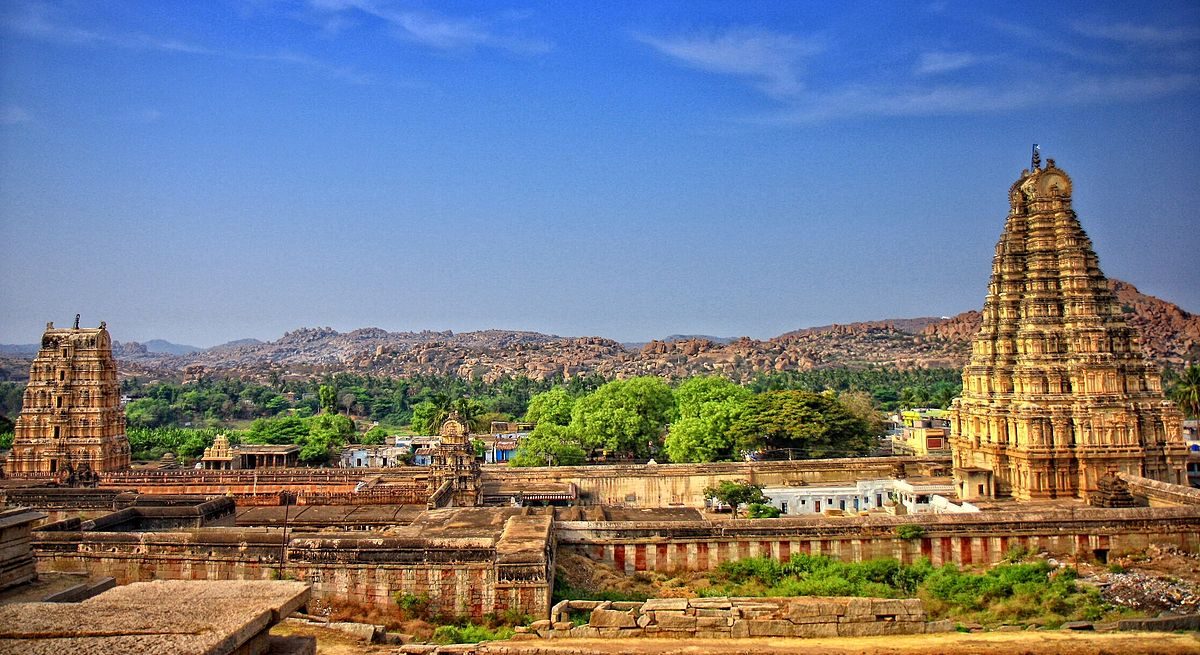Write a detailed description of the given image. The image depicts the Virupaksha Temple, a magnificent and ancient Hindu sanctuary located in the World Heritage Site of Hampi, Karnataka, India. Perched amid the boulder-strewn landscape, the temple's primary gopuram towers skyward, an emblem of Dravidian architecture, characterized by its pyramidal structure and profuse sculptural work depicting mythological scenes. It is a central part of the larger Hampi Bazaar, both of which lie at the heart of the city's historical and religious life.

Sprawling complex can be seen encased within tall boundary walls, hinting at the temple's protective encapsulation of its sacred precincts. In the distance, the craggy hilltops of Hampi provide a rugged backdrop, indicative of the region's topography and rich geological history, which are as much a part of Hampi's allure as its man-made wonders. The landscape surrounding the temple complex is interspersed with verdant foliage and intermittent clusters of human habitation, suggesting a harmony between cultural feats and natural beauty. This image encapsulates not just the temple's grandeur, but the spirit of an ancient city that was once the epicenter of the Vijayanagara Empire, conveying a sense of historic awe to the observer. 